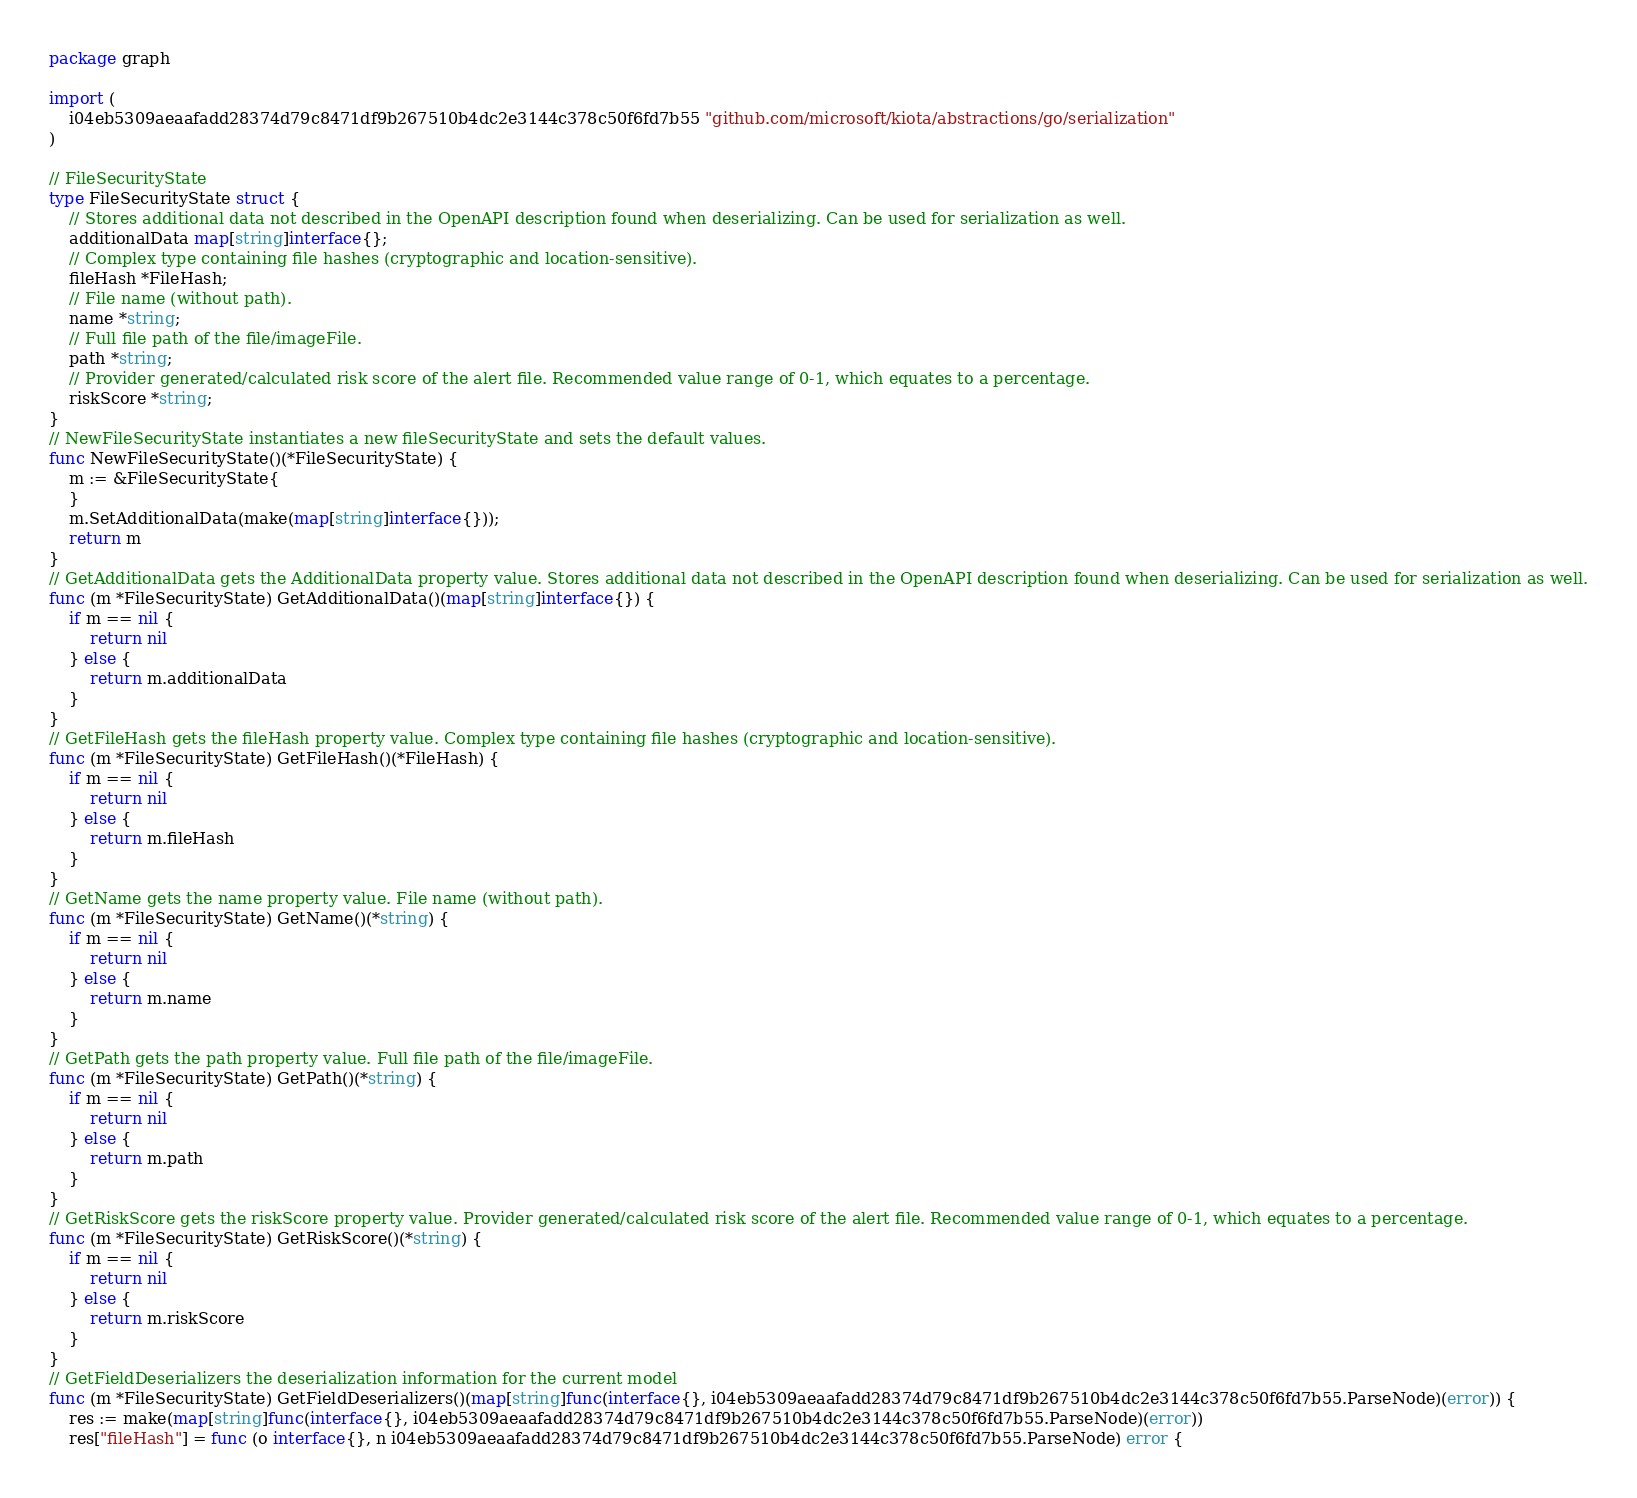<code> <loc_0><loc_0><loc_500><loc_500><_Go_>package graph

import (
    i04eb5309aeaafadd28374d79c8471df9b267510b4dc2e3144c378c50f6fd7b55 "github.com/microsoft/kiota/abstractions/go/serialization"
)

// FileSecurityState 
type FileSecurityState struct {
    // Stores additional data not described in the OpenAPI description found when deserializing. Can be used for serialization as well.
    additionalData map[string]interface{};
    // Complex type containing file hashes (cryptographic and location-sensitive).
    fileHash *FileHash;
    // File name (without path).
    name *string;
    // Full file path of the file/imageFile.
    path *string;
    // Provider generated/calculated risk score of the alert file. Recommended value range of 0-1, which equates to a percentage.
    riskScore *string;
}
// NewFileSecurityState instantiates a new fileSecurityState and sets the default values.
func NewFileSecurityState()(*FileSecurityState) {
    m := &FileSecurityState{
    }
    m.SetAdditionalData(make(map[string]interface{}));
    return m
}
// GetAdditionalData gets the AdditionalData property value. Stores additional data not described in the OpenAPI description found when deserializing. Can be used for serialization as well.
func (m *FileSecurityState) GetAdditionalData()(map[string]interface{}) {
    if m == nil {
        return nil
    } else {
        return m.additionalData
    }
}
// GetFileHash gets the fileHash property value. Complex type containing file hashes (cryptographic and location-sensitive).
func (m *FileSecurityState) GetFileHash()(*FileHash) {
    if m == nil {
        return nil
    } else {
        return m.fileHash
    }
}
// GetName gets the name property value. File name (without path).
func (m *FileSecurityState) GetName()(*string) {
    if m == nil {
        return nil
    } else {
        return m.name
    }
}
// GetPath gets the path property value. Full file path of the file/imageFile.
func (m *FileSecurityState) GetPath()(*string) {
    if m == nil {
        return nil
    } else {
        return m.path
    }
}
// GetRiskScore gets the riskScore property value. Provider generated/calculated risk score of the alert file. Recommended value range of 0-1, which equates to a percentage.
func (m *FileSecurityState) GetRiskScore()(*string) {
    if m == nil {
        return nil
    } else {
        return m.riskScore
    }
}
// GetFieldDeserializers the deserialization information for the current model
func (m *FileSecurityState) GetFieldDeserializers()(map[string]func(interface{}, i04eb5309aeaafadd28374d79c8471df9b267510b4dc2e3144c378c50f6fd7b55.ParseNode)(error)) {
    res := make(map[string]func(interface{}, i04eb5309aeaafadd28374d79c8471df9b267510b4dc2e3144c378c50f6fd7b55.ParseNode)(error))
    res["fileHash"] = func (o interface{}, n i04eb5309aeaafadd28374d79c8471df9b267510b4dc2e3144c378c50f6fd7b55.ParseNode) error {</code> 